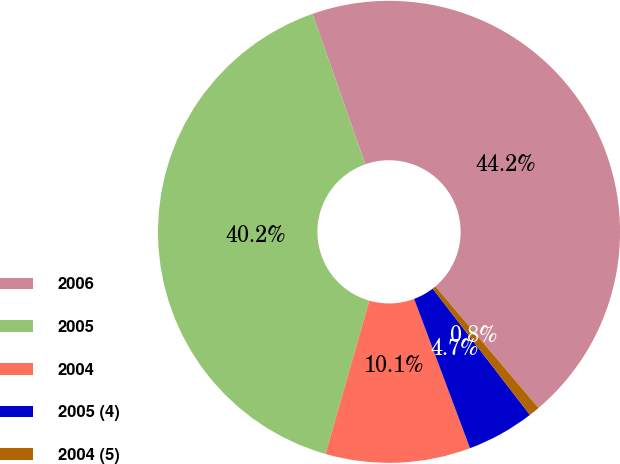Convert chart. <chart><loc_0><loc_0><loc_500><loc_500><pie_chart><fcel>2006<fcel>2005<fcel>2004<fcel>2005 (4)<fcel>2004 (5)<nl><fcel>44.17%<fcel>40.19%<fcel>10.13%<fcel>4.74%<fcel>0.76%<nl></chart> 